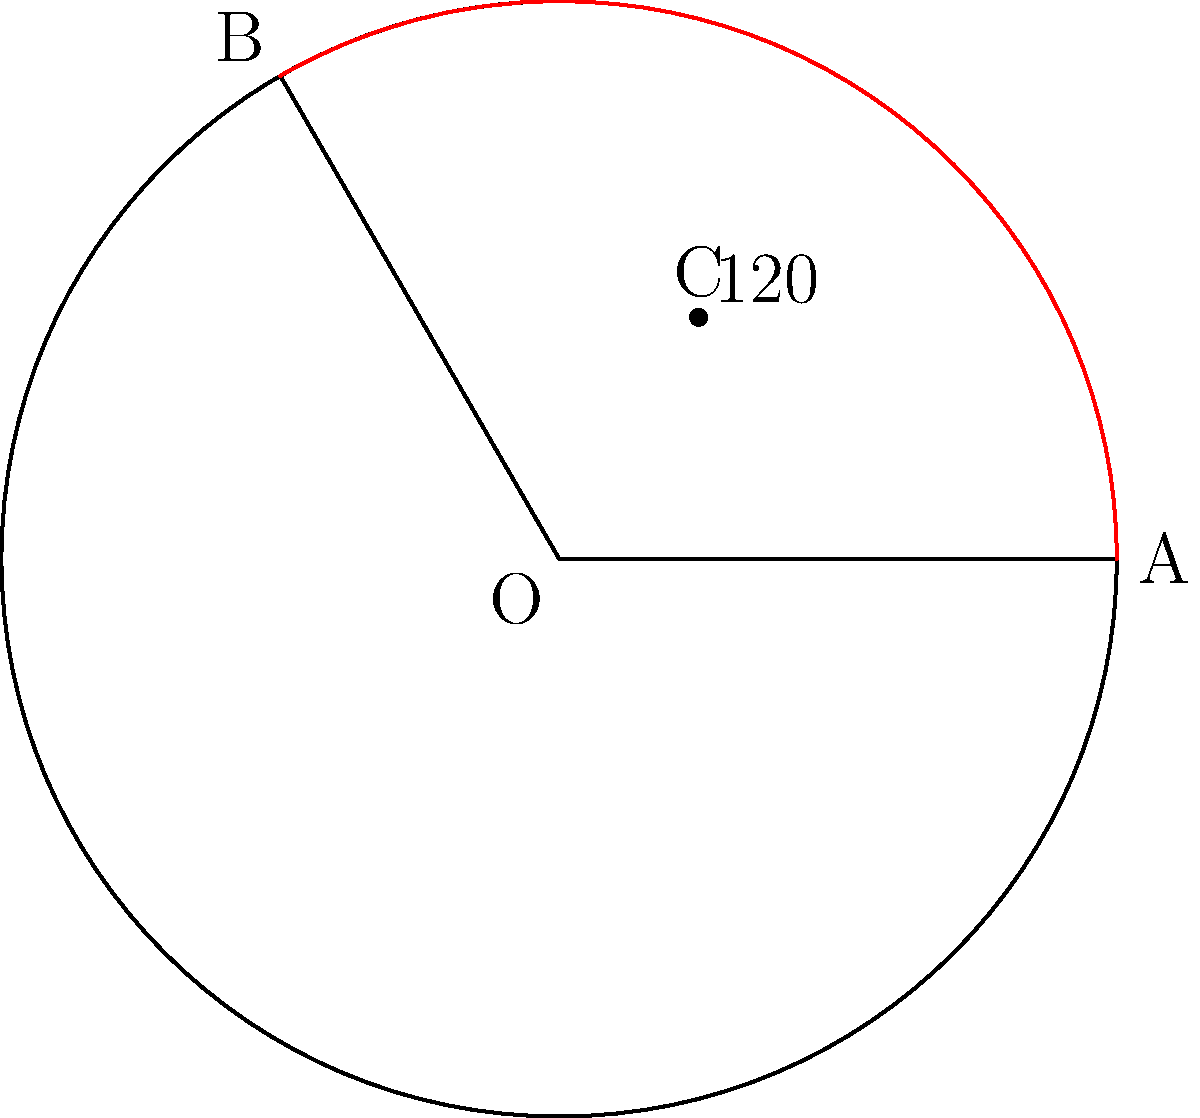In a circular bunker designed to protect against mutant attacks, a sector is cordoned off for emergency supplies. If the bunker has a radius of 15 meters and the sector's central angle is $120°$, what is the area of this sector in square meters? Round your answer to two decimal places. To find the area of a sector, we need to follow these steps:

1) The formula for the area of a sector is:

   $$A = \frac{\theta}{360°} \pi r^2$$

   Where $\theta$ is the central angle in degrees, and $r$ is the radius.

2) We are given:
   - Radius $(r) = 15$ meters
   - Central angle $(\theta) = 120°$

3) Let's substitute these values into our formula:

   $$A = \frac{120°}{360°} \pi (15)^2$$

4) Simplify:
   $$A = \frac{1}{3} \pi (225)$$

5) Calculate:
   $$A = 75\pi$$

6) Use $\pi \approx 3.14159$:
   $$A \approx 75 * 3.14159 = 235.61925$$

7) Rounding to two decimal places:
   $$A \approx 235.62 \text{ square meters}$$
Answer: 235.62 m² 